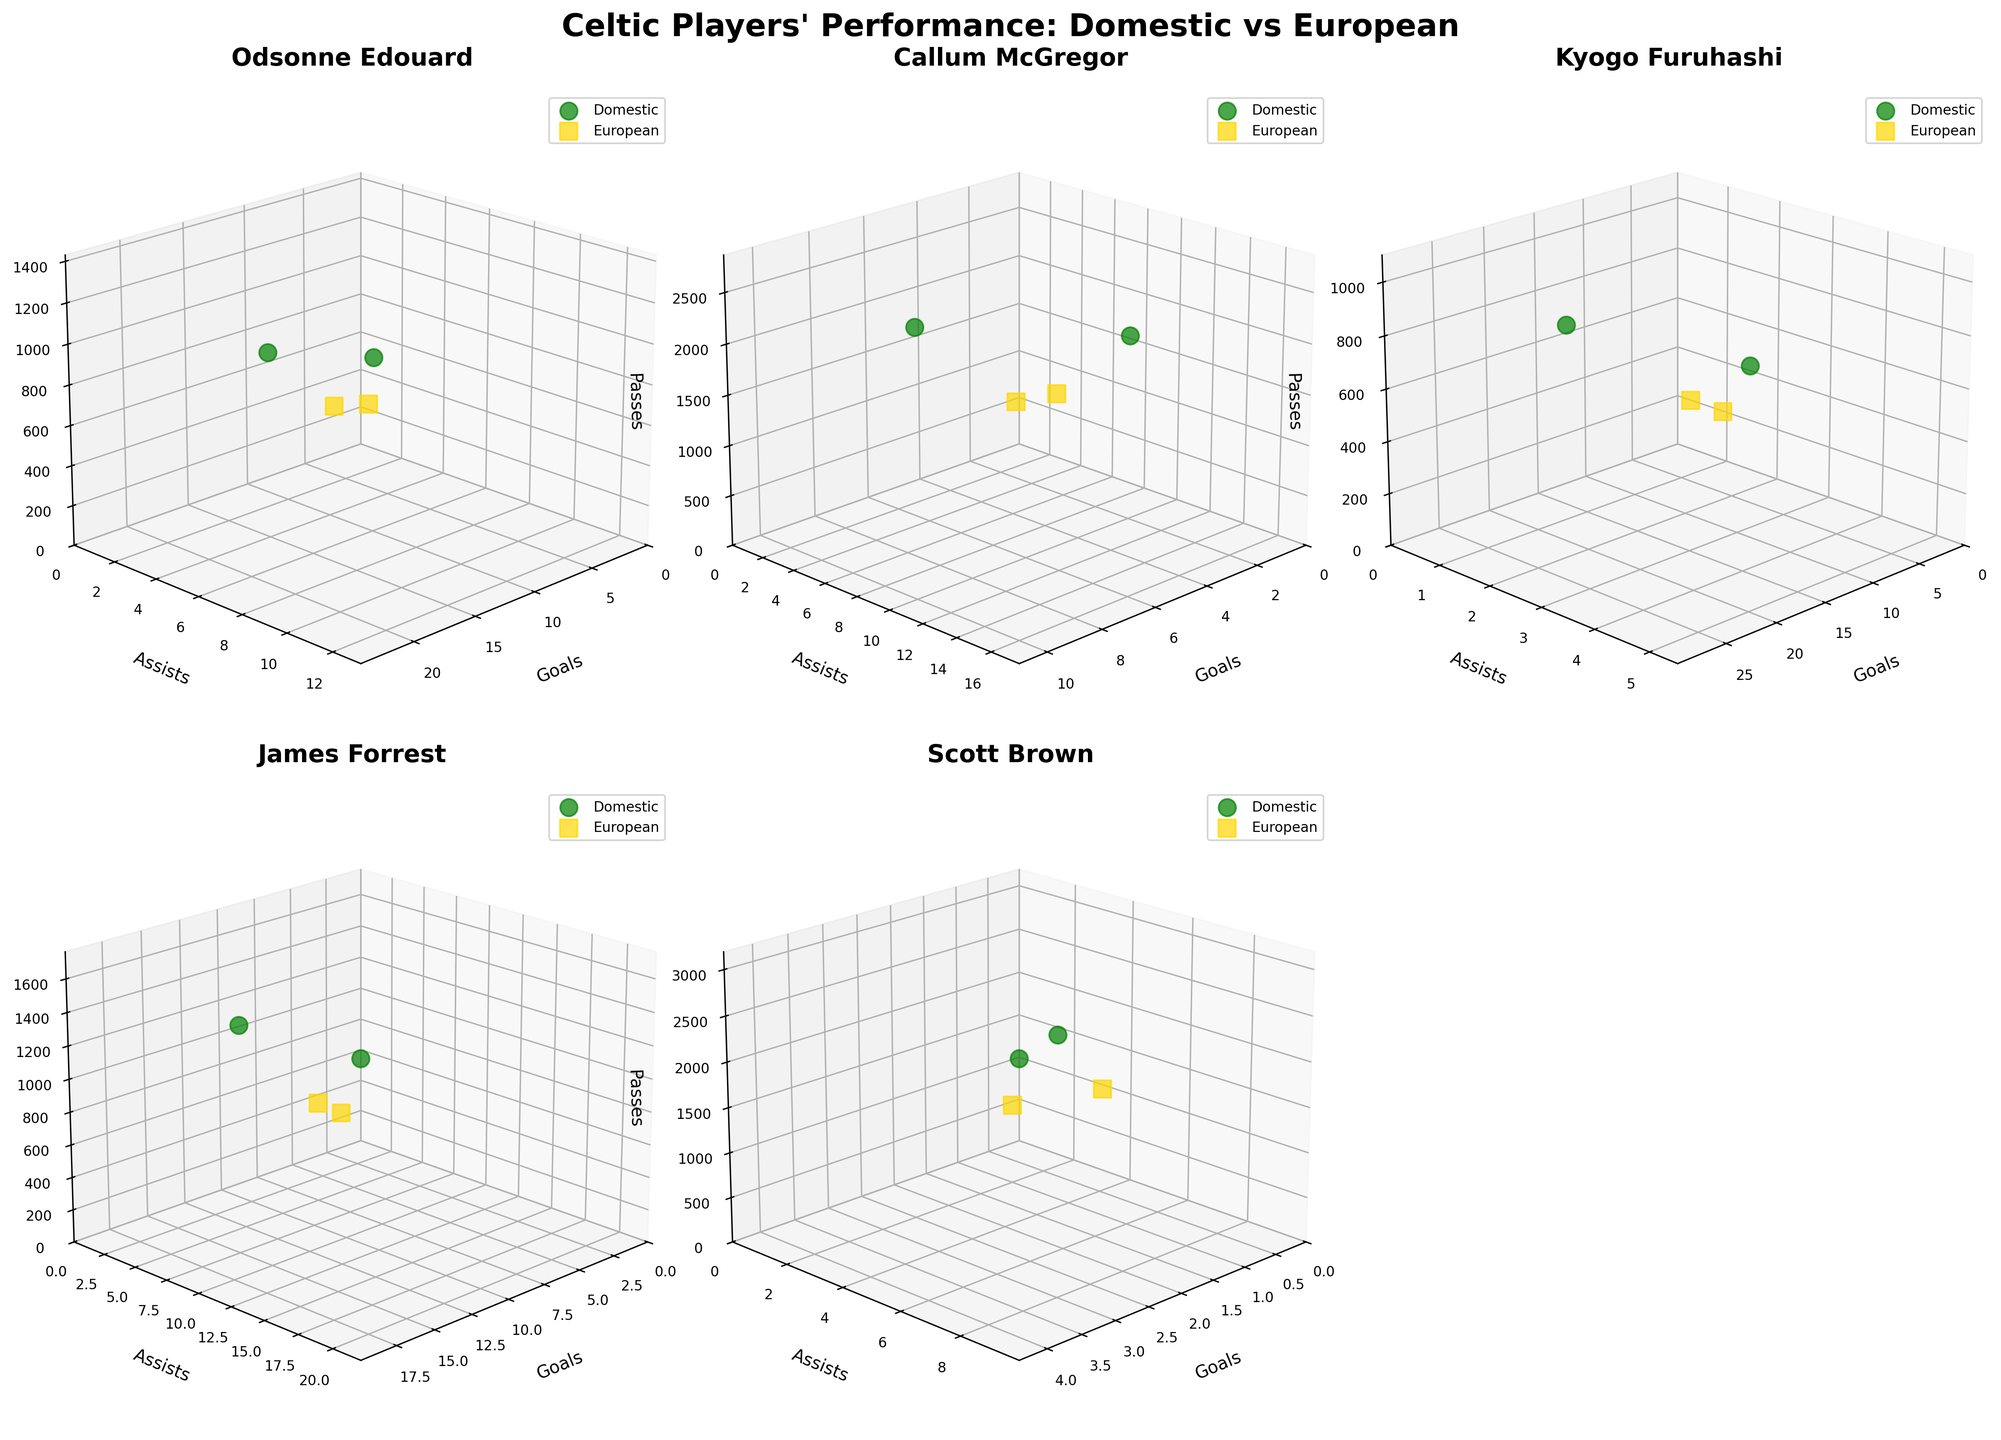What's the title of the figure? The title is usually located at the top of the figure. It should be descriptive of the content presented in the subplots. In this case, the title is "Celtic Players' Performance: Domestic vs European" because it is set explicitly in the code.
Answer: "Celtic Players' Performance: Domestic vs European" How are domestic and European performances visually distinguished on the plots? Domestic and European performances are shown using different colors and markers. The domestic competition is represented by green ('#008000') markers while the European competition is represented by gold ('#FFD700') markers, as determined by the `colors` and `markers` lists in the code.
Answer: By colors (green for domestic, gold for European) and markers Which player has the highest number of goals in domestic competitions across all plots? You need to inspect each player's 3D plot for the domestic competition and compare the goal values. Odsonne Edouard's plot shows a domestic goals value of 27 for the 2022-23 season.
Answer: Odsonne Edouard For Callum McGregor, is there a significant difference in the number of passes between domestic and European competitions? Examine Callum McGregor's subplot and compare the number of passes. His highest domestic passes are around 2600, while his European passes are 850 at most. This large difference indicates a significant disparity.
Answer: Yes, significant How do Kyogo Furuhashi's assists in domestic competitions compare to his assists in European competitions? Look at Kyogo Furuhashi's subplot. His assists in domestic competitions are significantly higher, peaking at 5 and 3 respectively, compared to his assists in European competitions which are 1 and 2.
Answer: Higher in domestic Between Odsonne Edouard and James Forrest, who has more assists in European competitions in the 2018-19 season? Compare the assists for both players in European competitions for the 2018-19 season. Odsonne Edouard has 2 assists, while James Forrest has 4. Thus, James Forrest has more assists.
Answer: James Forrest Which competition type shows more consistent passing numbers across all players? Assess the Z-axis (passes) variability for both domestic and European competitions across all subplots. Domestic performance usually showcases a wider range but remains consistently high among most players. European competition has a wider variability, especially with lower counts.
Answer: Domestic In terms of goals and assists, how does Scott Brown's domestic performance compare to his European performance? Scott Brown’s domestic plot indicates goals and assists values of 3-4 and 8-9, respectively. In his European plot, the values substantially drop to 0-1 goals and 2-3 assists. This indicates a noticeable drop in his European performance.
Answer: Better in domestic Which player has the most balanced (similar) performance metrics between domestic and European competitions in terms of goals, assists, and passes? A balanced performance indicates similar values across goals, assists, and passes in both types of competition. Comparing each plot, Odsonne Edouard has relatively smaller disparities in metrics between the two competitions, especially in the 2019-20 season.
Answer: Odsonne Edouard 